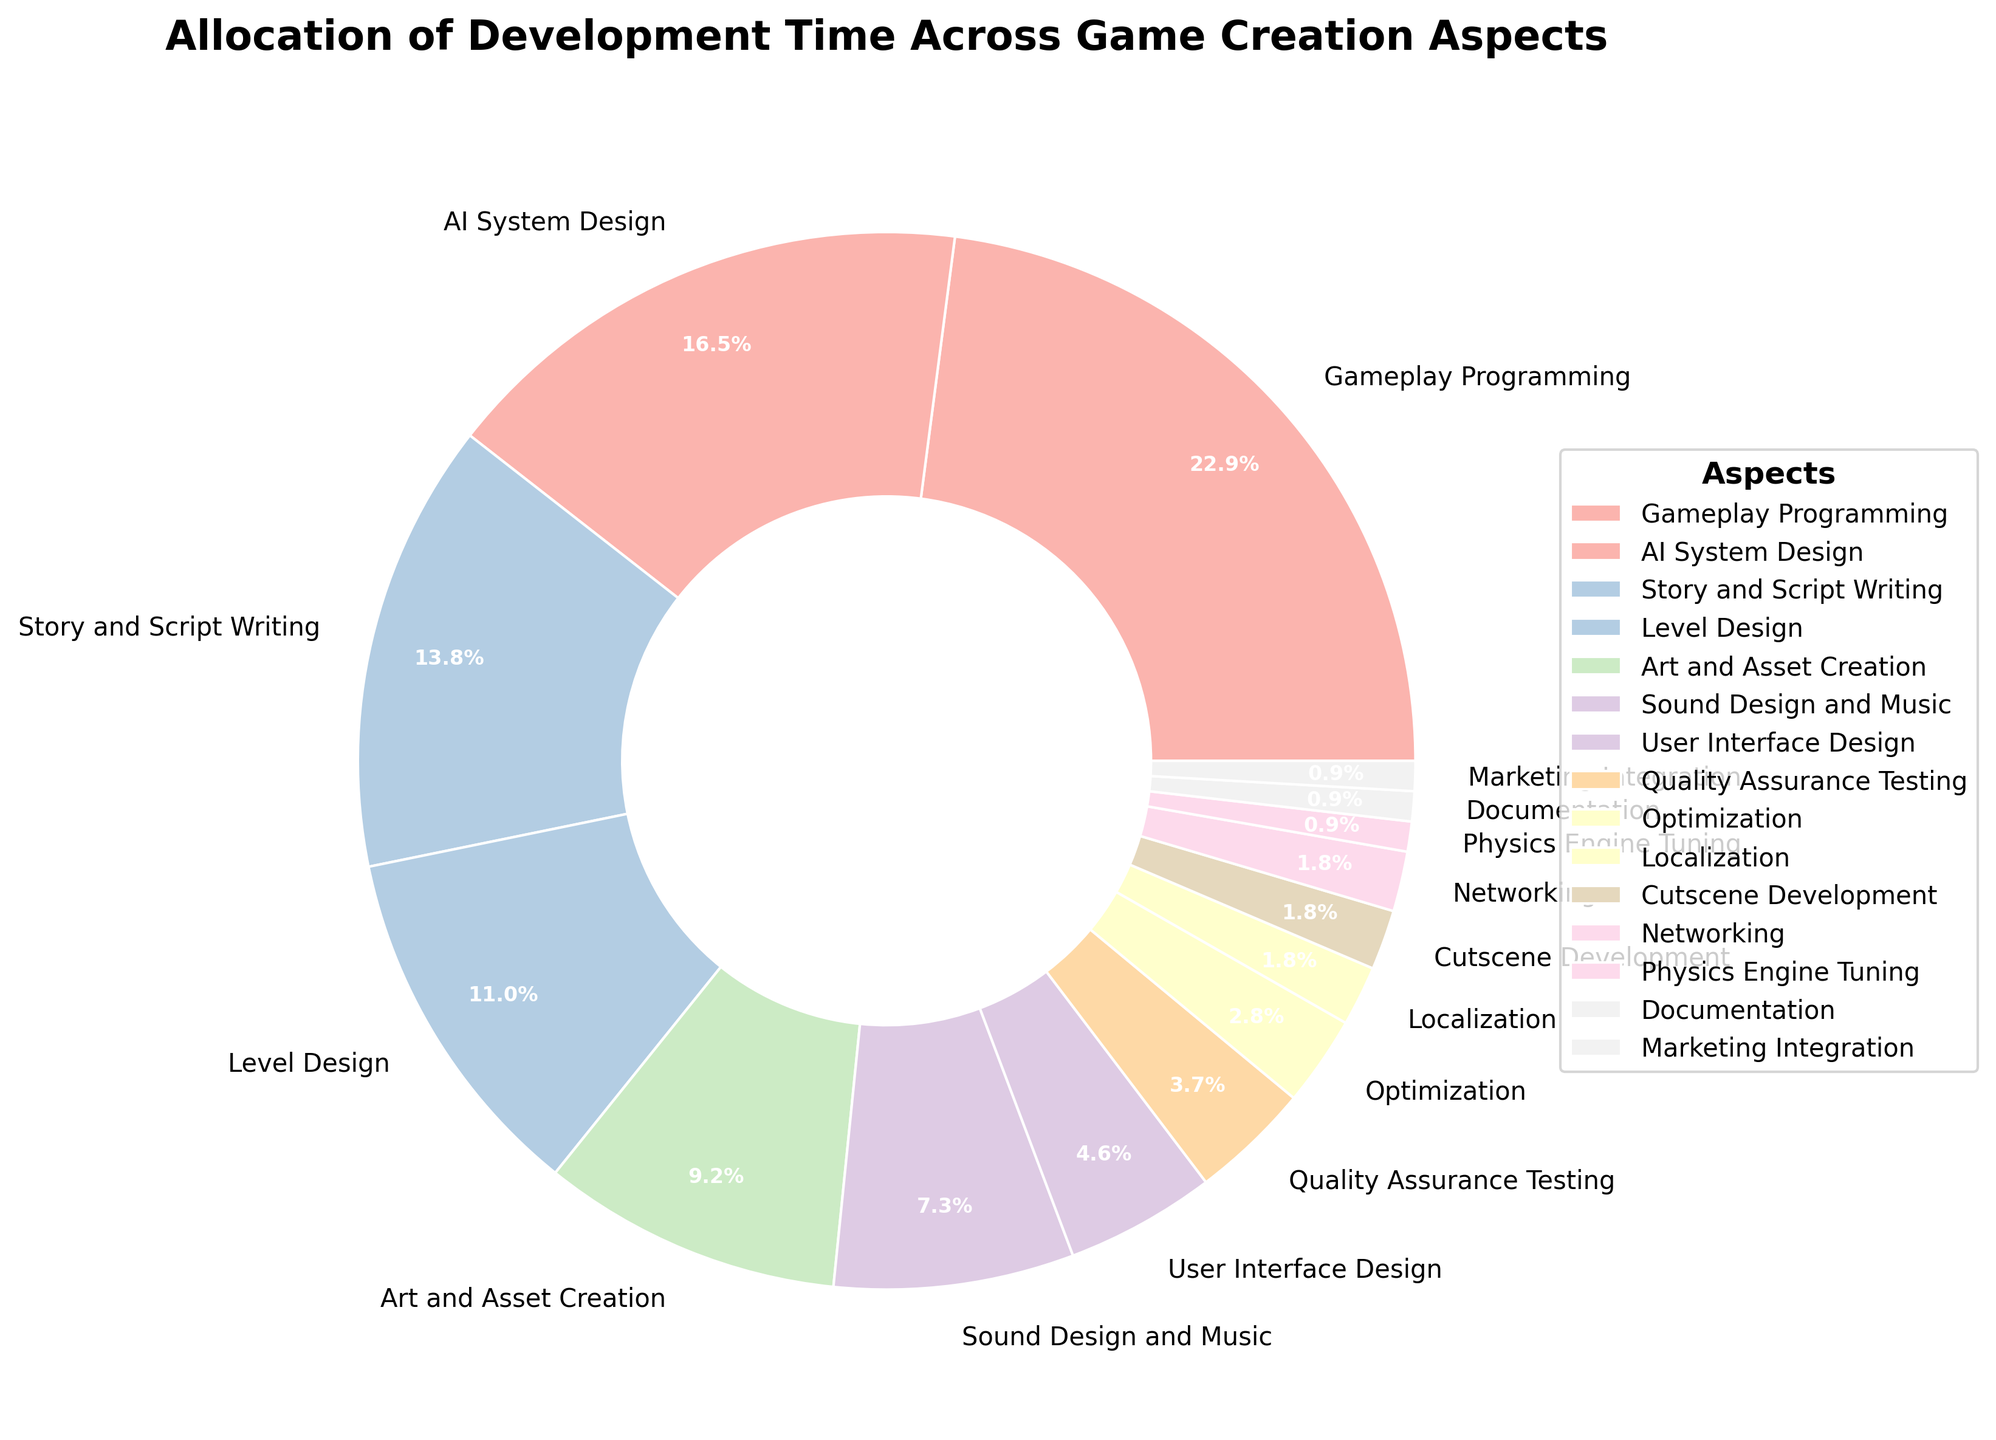Which aspect has the highest allocation of development time? The aspect with the highest percentage segment in the pie chart represents the largest allocation of development time. Referring to the chart, the largest segment corresponds to "Gameplay Programming" with 25%.
Answer: Gameplay Programming How does the allocation time for AI System Design compare to Sound Design and Music? Look at the percentages for both aspects: AI System Design is 18%, and Sound Design and Music is 8%. AI System Design has a higher allocation time.
Answer: AI System Design has more time allocated What is the combined percentage of time allocated to Level Design, Art and Asset Creation, and Sound Design and Music? Add the percentages for Level Design (12%), Art and Asset Creation (10%), and Sound Design and Music (8%). The combined percentage is 12% + 10% + 8% = 30%.
Answer: 30% What is the difference in percentage allocation between Story and Script Writing and User Interface Design? Subtract the percentage for User Interface Design (5%) from the percentage for Story and Script Writing (15%). The difference is 15% - 5% = 10%.
Answer: 10% Which aspect has the smallest allocation of development time? The aspect with the smallest percentage segment in the pie chart represents the smallest allocation of development time. Referring to the chart, the smallest segment corresponds to "Documentation," "Marketing Integration," and "Physics Engine Tuning," each with 1%.
Answer: Documentation, Marketing Integration, Physics Engine Tuning How much more time is allocated to Gameplay Programming compared to Cutscene Development and Networking combined? Add the percentages for Cutscene Development (2%) and Networking (2%) to get 4%. Subtract this from the percentage for Gameplay Programming (25%). The difference is 25% - 4% = 21%.
Answer: 21% Compare the allocation time for Localization and Optimization. Localization has 2% allocation, while Optimization has 3%. Therefore, Optimization has a higher allocation time.
Answer: Optimization has more time allocated What is the total percentage of time allocated to areas involving visuals (Art and Asset Creation, Level Design, Cutscene Development, User Interface Design)? Add the percentages for Art and Asset Creation (10%), Level Design (12%), Cutscene Development (2%), and User Interface Design (5%). The total is 10% + 12% + 2% + 5% = 29%.
Answer: 29% What percentage of development time is allocated to aspects that are directly user-facing (Gameplay Programming, Story and Script Writing, User Interface Design, Sound Design and Music)? Add the percentages for Gameplay Programming (25%), Story and Script Writing (15%), User Interface Design (5%), and Sound Design and Music (8%). The total is 25% + 15% + 5% + 8% = 53%.
Answer: 53% 